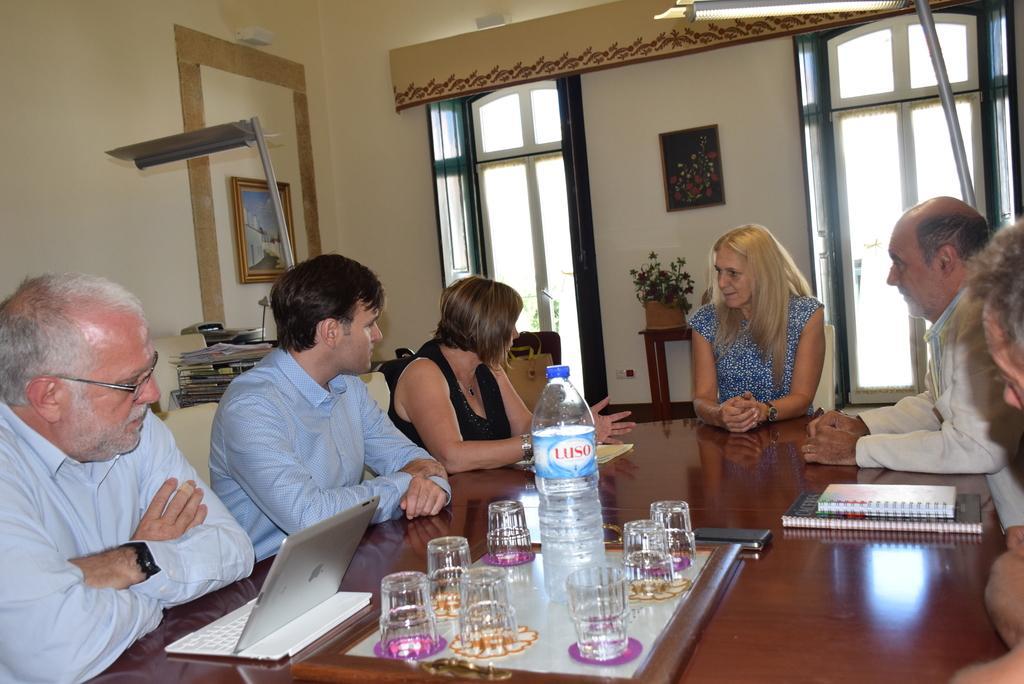Can you describe this image briefly? This picture shows a group of people seated on the chairs and speaking to each other and we see few glasses and a water bottle and few books and iPad on the table and we see couple of photo frames on the wall 